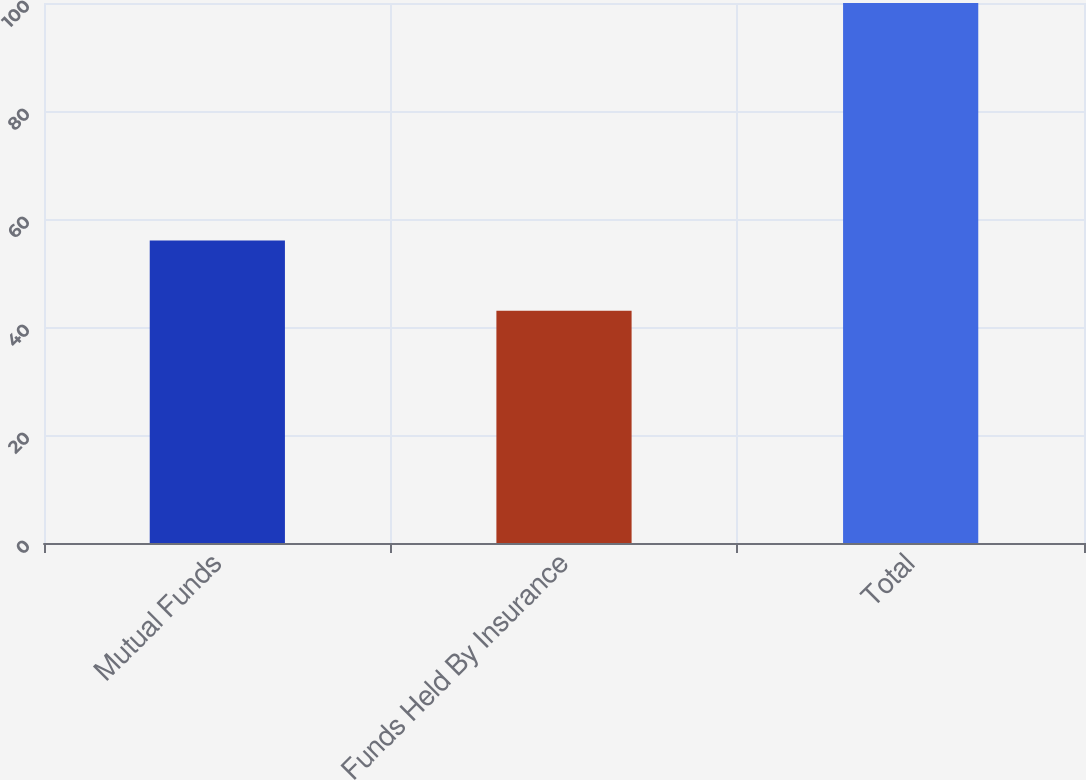<chart> <loc_0><loc_0><loc_500><loc_500><bar_chart><fcel>Mutual Funds<fcel>Funds Held By Insurance<fcel>Total<nl><fcel>56<fcel>43<fcel>100<nl></chart> 